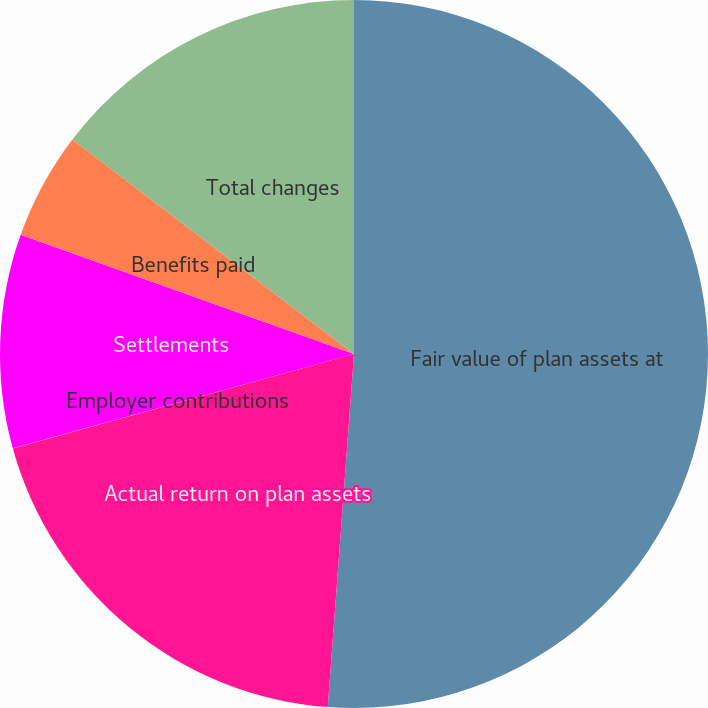Convert chart. <chart><loc_0><loc_0><loc_500><loc_500><pie_chart><fcel>Fair value of plan assets at<fcel>Actual return on plan assets<fcel>Employer contributions<fcel>Settlements<fcel>Benefits paid<fcel>Total changes<nl><fcel>51.18%<fcel>19.52%<fcel>0.01%<fcel>9.76%<fcel>4.89%<fcel>14.64%<nl></chart> 